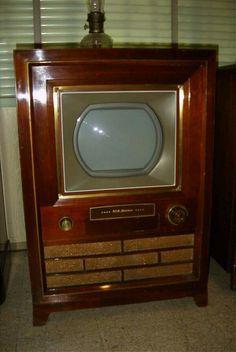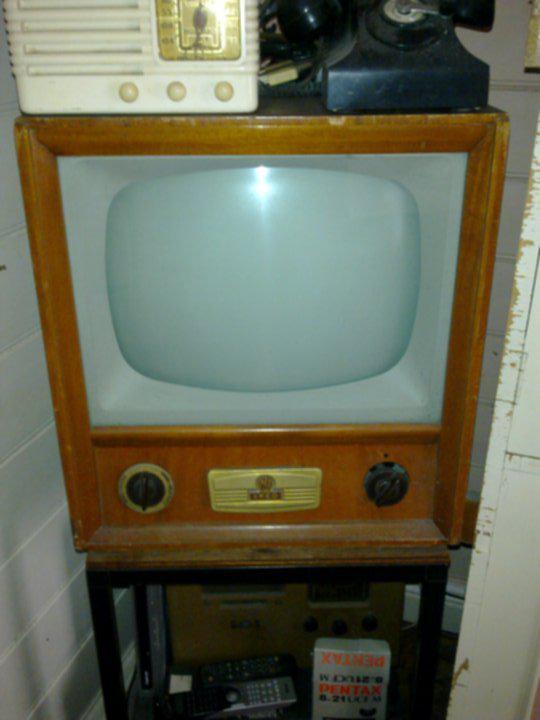The first image is the image on the left, the second image is the image on the right. Evaluate the accuracy of this statement regarding the images: "Each of two older television sets is in a wooden case with a gold tone rim around the picture tube, and two or four control knobs underneath.". Is it true? Answer yes or no. No. The first image is the image on the left, the second image is the image on the right. For the images shown, is this caption "At least one image shows a TV screen that is flat on the top and bottom, and curved on the sides." true? Answer yes or no. Yes. 